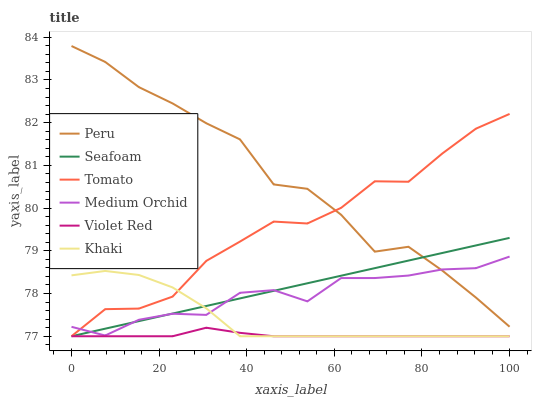Does Khaki have the minimum area under the curve?
Answer yes or no. No. Does Khaki have the maximum area under the curve?
Answer yes or no. No. Is Violet Red the smoothest?
Answer yes or no. No. Is Violet Red the roughest?
Answer yes or no. No. Does Medium Orchid have the lowest value?
Answer yes or no. No. Does Khaki have the highest value?
Answer yes or no. No. Is Khaki less than Peru?
Answer yes or no. Yes. Is Peru greater than Violet Red?
Answer yes or no. Yes. Does Khaki intersect Peru?
Answer yes or no. No. 